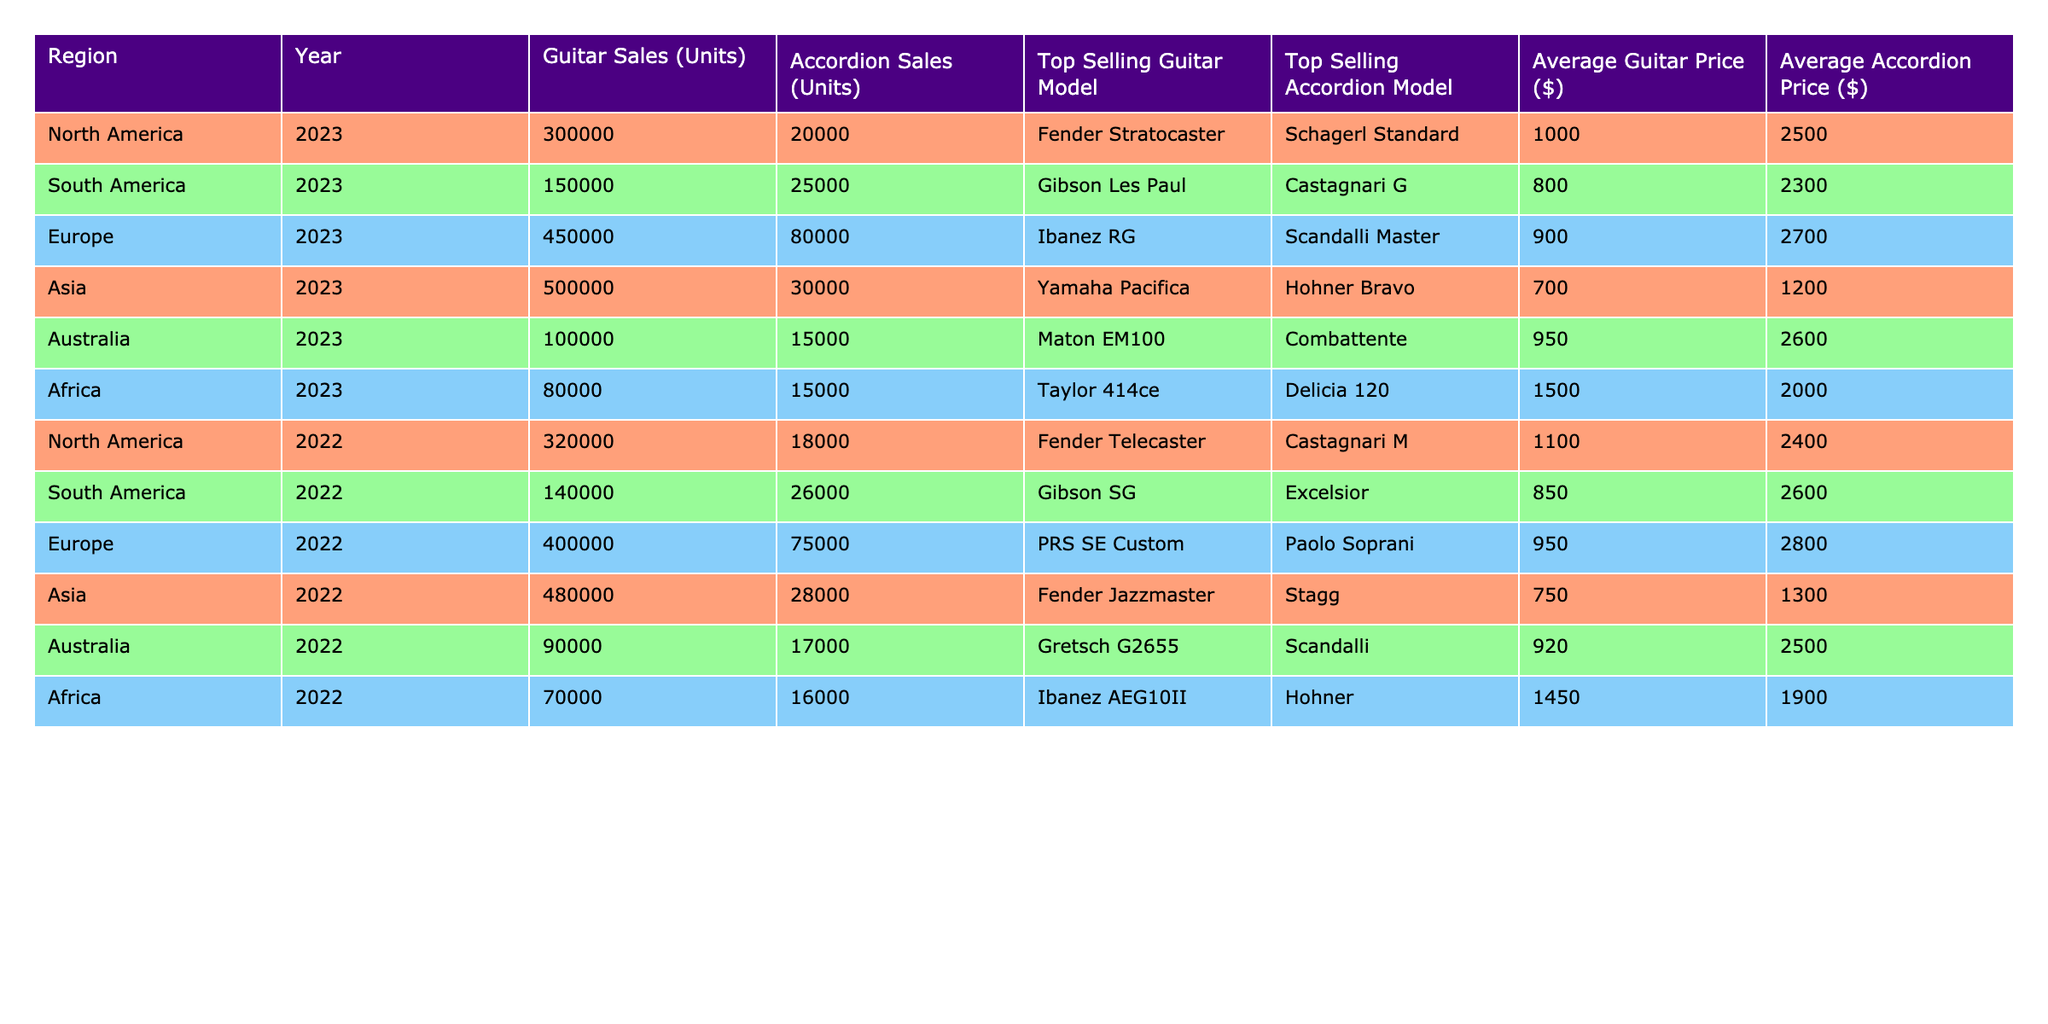What is the total number of guitar sales in Asia in 2023? The table shows that Asia had 500,000 guitar sales in 2023, which is directly recorded under that column.
Answer: 500000 Which accordion model sold the most in North America in 2023? The table indicates that the top-selling accordion model in North America in 2023 is the Schagerl Standard, as listed in the relevant column for that region and year.
Answer: Schagerl Standard What is the average price of guitars sold in Europe for 2023? According to the table, the average guitar price in Europe in 2023 is $900, which is noted in the row for Europe under the Average Guitar Price column.
Answer: 900 Are guitar sales higher in South America or Africa in 2023? The table records 150,000 guitar sales in South America and 80,000 in Africa for 2023. South America has higher sales than Africa, as 150,000 is greater than 80,000.
Answer: South America What is the combined total of accordion sales in Europe and Asia for 2023? From the table, Europe has 80,000 accordion sales and Asia has 30,000 in 2023. Adding these amounts together: 80,000 + 30,000 = 110,000.
Answer: 110000 Which region had the lowest average accordion price in 2022? The table shows that Africa had the lowest average accordion price at $1,900 in 2022, which is less than the prices listed for other regions in that year.
Answer: Africa What is the percentage increase in guitar sales from North America in 2022 to 2023? North America sold 320,000 guitars in 2022 and 300,000 in 2023. The change is (300,000 - 320,000) = -20,000. The percentage increase is then calculated as (-20,000/320,000)*100 = -6.25%. This indicates a decrease.
Answer: -6.25% What was the top-selling guitar model in Europe in 2022? The table shows that the top-selling guitar model in Europe in 2022 is the PRS SE Custom, which is specifically listed under the corresponding data for that year and region.
Answer: PRS SE Custom Is the average guitar price in Asia less than the average accordion price in South America for 2023? The average guitar price in Asia is $700 while the average accordion price in South America is $2,300. Since $700 is less than $2,300, the answer is yes.
Answer: Yes How many more accordion units were sold in Europe than in Australia in 2022? Europe sold 75,000 accordion units, while Australia sold 17,000 in 2022. The difference is 75,000 - 17,000 = 58,000 units more sold in Europe.
Answer: 58000 